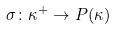Convert formula to latex. <formula><loc_0><loc_0><loc_500><loc_500>\sigma \colon \kappa ^ { + } \rightarrow P ( \kappa )</formula> 